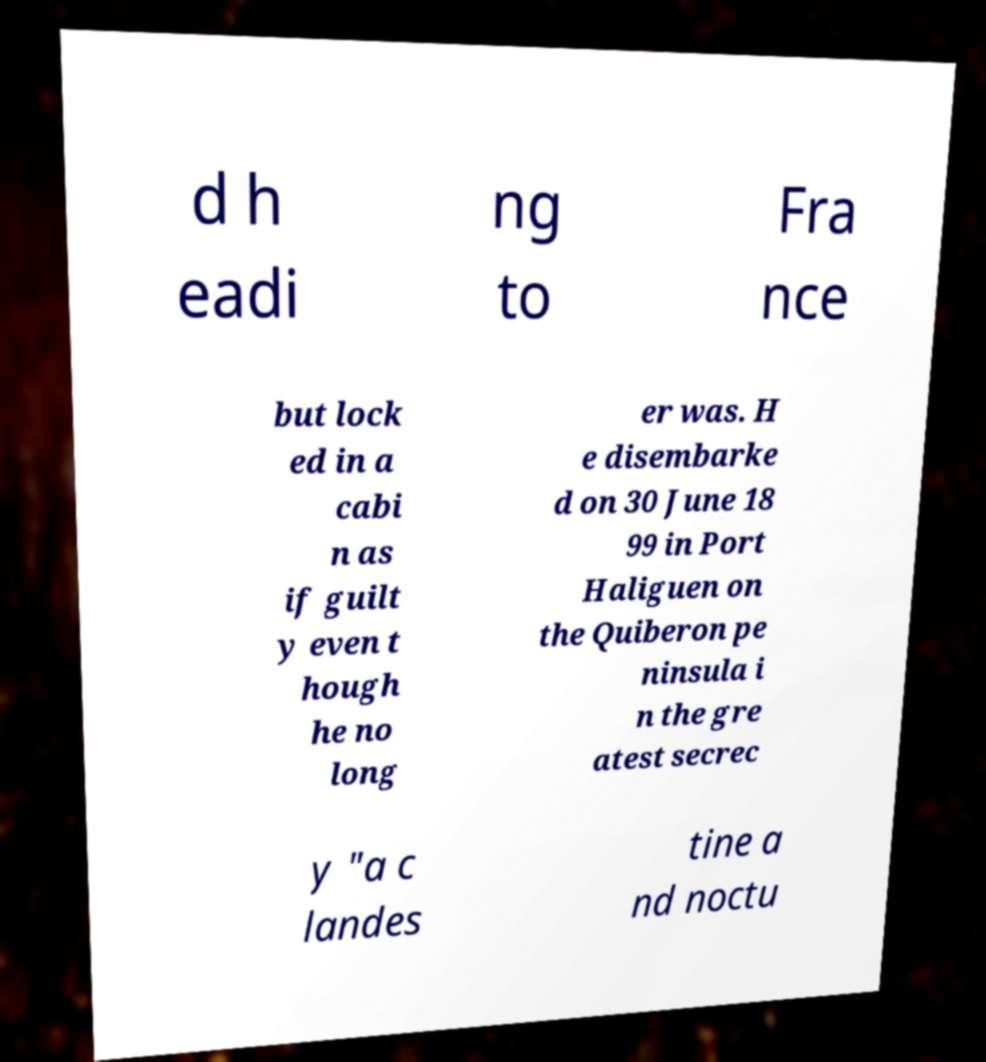I need the written content from this picture converted into text. Can you do that? d h eadi ng to Fra nce but lock ed in a cabi n as if guilt y even t hough he no long er was. H e disembarke d on 30 June 18 99 in Port Haliguen on the Quiberon pe ninsula i n the gre atest secrec y "a c landes tine a nd noctu 